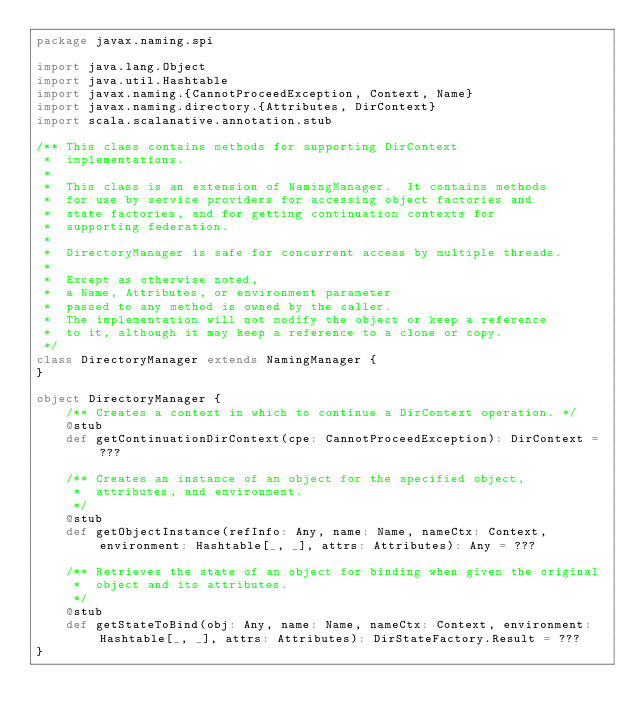Convert code to text. <code><loc_0><loc_0><loc_500><loc_500><_Scala_>package javax.naming.spi

import java.lang.Object
import java.util.Hashtable
import javax.naming.{CannotProceedException, Context, Name}
import javax.naming.directory.{Attributes, DirContext}
import scala.scalanative.annotation.stub

/** This class contains methods for supporting DirContext
 *  implementations.
 * 
 *  This class is an extension of NamingManager.  It contains methods
 *  for use by service providers for accessing object factories and
 *  state factories, and for getting continuation contexts for
 *  supporting federation.
 * 
 *  DirectoryManager is safe for concurrent access by multiple threads.
 * 
 *  Except as otherwise noted,
 *  a Name, Attributes, or environment parameter
 *  passed to any method is owned by the caller.
 *  The implementation will not modify the object or keep a reference
 *  to it, although it may keep a reference to a clone or copy.
 */
class DirectoryManager extends NamingManager {
}

object DirectoryManager {
    /** Creates a context in which to continue a DirContext operation. */
    @stub
    def getContinuationDirContext(cpe: CannotProceedException): DirContext = ???

    /** Creates an instance of an object for the specified object,
     *  attributes, and environment.
     */
    @stub
    def getObjectInstance(refInfo: Any, name: Name, nameCtx: Context, environment: Hashtable[_, _], attrs: Attributes): Any = ???

    /** Retrieves the state of an object for binding when given the original
     *  object and its attributes.
     */
    @stub
    def getStateToBind(obj: Any, name: Name, nameCtx: Context, environment: Hashtable[_, _], attrs: Attributes): DirStateFactory.Result = ???
}
</code> 